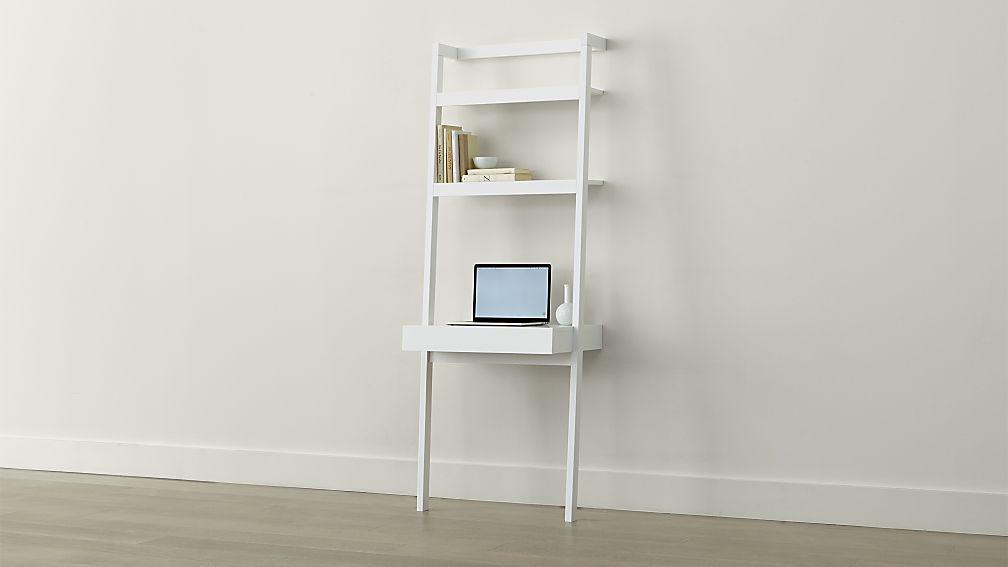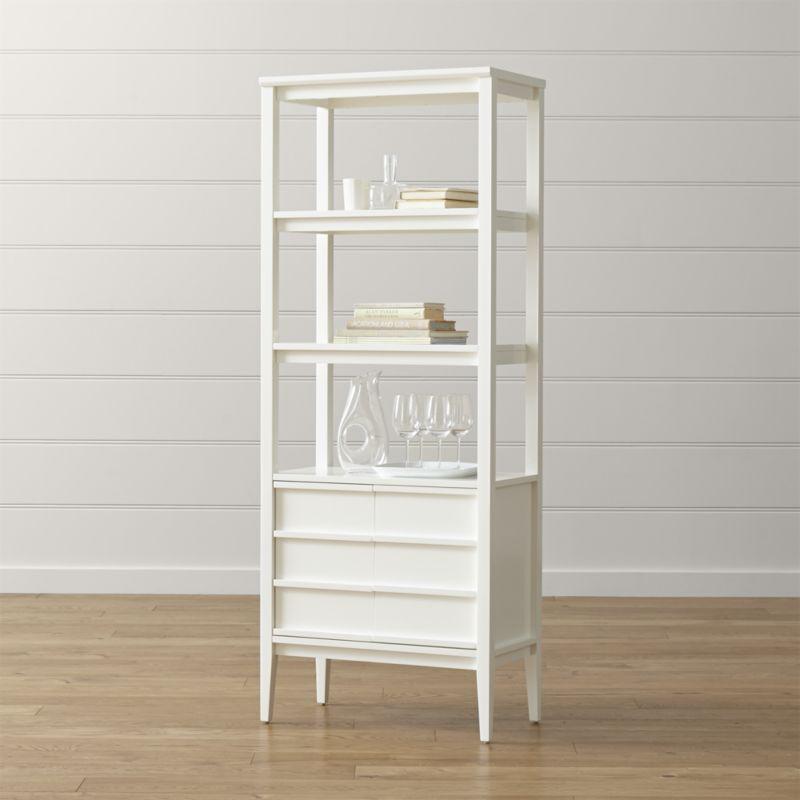The first image is the image on the left, the second image is the image on the right. Given the left and right images, does the statement "One image shows a single set of white shelves supported by a white wall." hold true? Answer yes or no. Yes. 